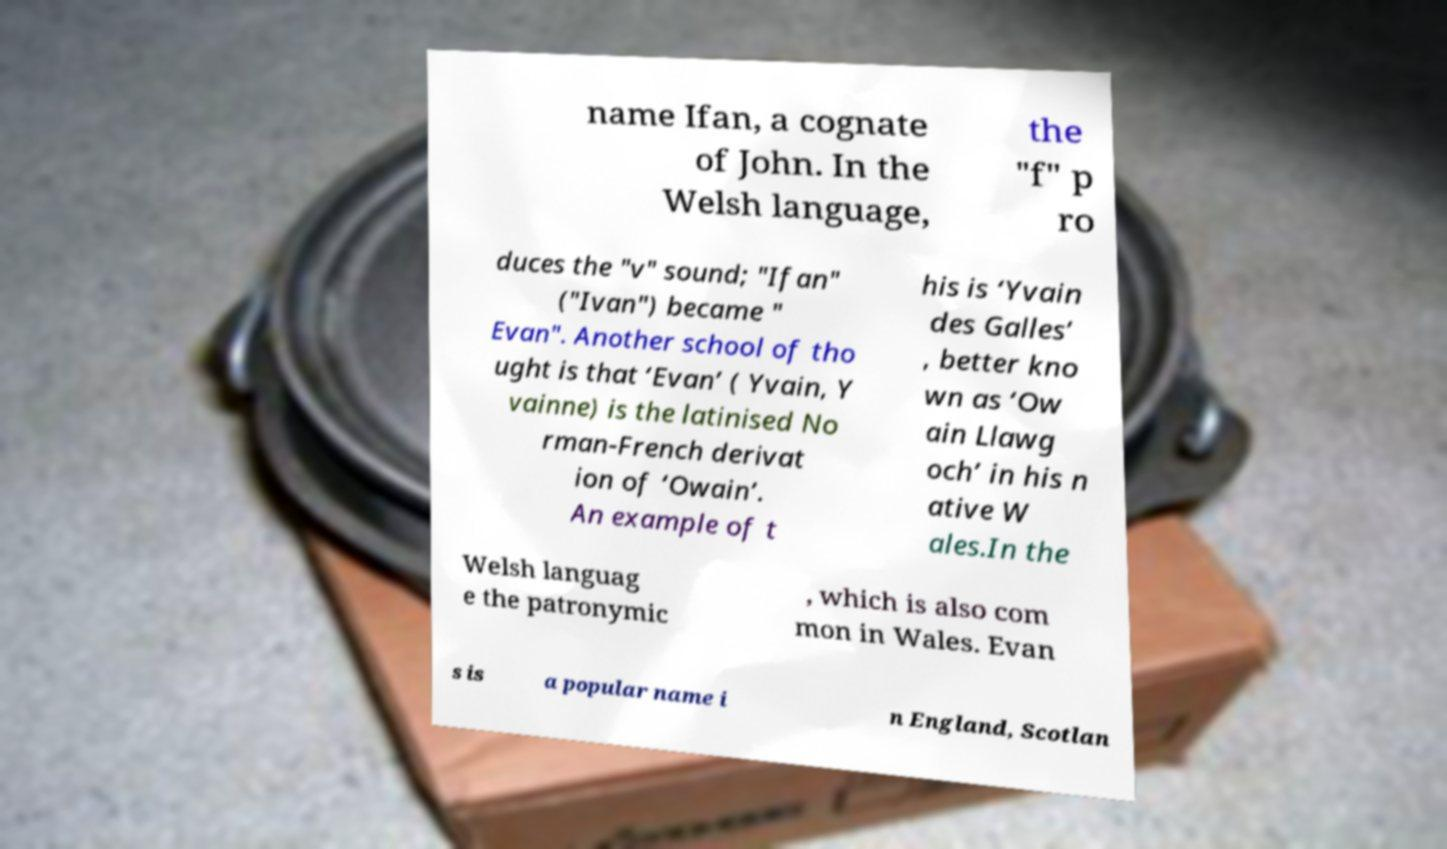I need the written content from this picture converted into text. Can you do that? name Ifan, a cognate of John. In the Welsh language, the "f" p ro duces the "v" sound; "Ifan" ("Ivan") became " Evan". Another school of tho ught is that ‘Evan’ ( Yvain, Y vainne) is the latinised No rman-French derivat ion of ‘Owain’. An example of t his is ‘Yvain des Galles’ , better kno wn as ‘Ow ain Llawg och’ in his n ative W ales.In the Welsh languag e the patronymic , which is also com mon in Wales. Evan s is a popular name i n England, Scotlan 